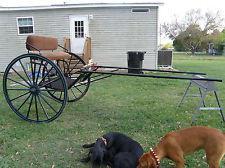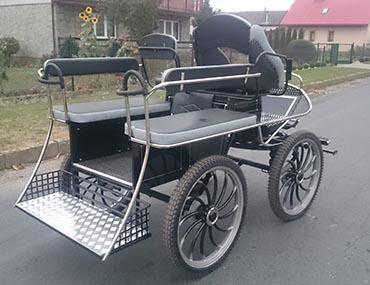The first image is the image on the left, the second image is the image on the right. Analyze the images presented: Is the assertion "There at least one person shown in one or both of the images." valid? Answer yes or no. No. The first image is the image on the left, the second image is the image on the right. Analyze the images presented: Is the assertion "One of the images has someone riding a horse carriage." valid? Answer yes or no. No. 